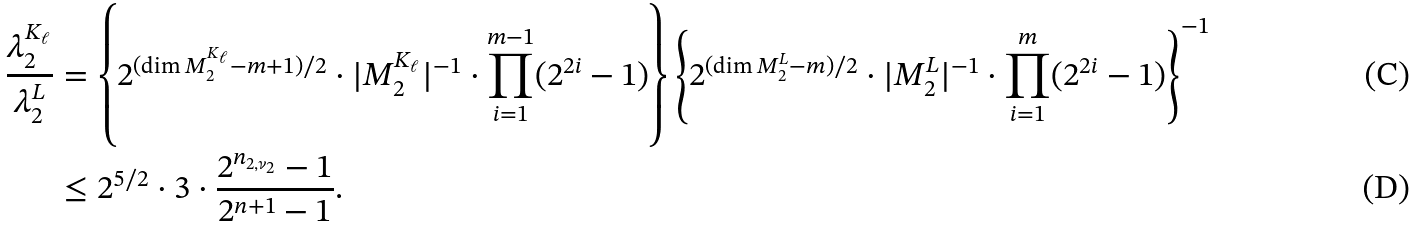<formula> <loc_0><loc_0><loc_500><loc_500>\frac { \lambda _ { 2 } ^ { K _ { \ell } } } { \lambda _ { 2 } ^ { L } } & = \left \{ 2 ^ { ( \dim M _ { 2 } ^ { K _ { \ell } } - m + 1 ) / 2 } \cdot | M _ { 2 } ^ { K _ { \ell } } | ^ { - 1 } \cdot \prod _ { i = 1 } ^ { m - 1 } ( 2 ^ { 2 i } - 1 ) \right \} \left \{ 2 ^ { ( \dim M _ { 2 } ^ { L } - m ) / 2 } \cdot | M _ { 2 } ^ { L } | ^ { - 1 } \cdot \prod _ { i = 1 } ^ { m } ( 2 ^ { 2 i } - 1 ) \right \} ^ { - 1 } \\ & \leq 2 ^ { 5 / 2 } \cdot 3 \cdot \frac { 2 ^ { n _ { 2 , \nu _ { 2 } } } - 1 } { 2 ^ { n + 1 } - 1 } .</formula> 